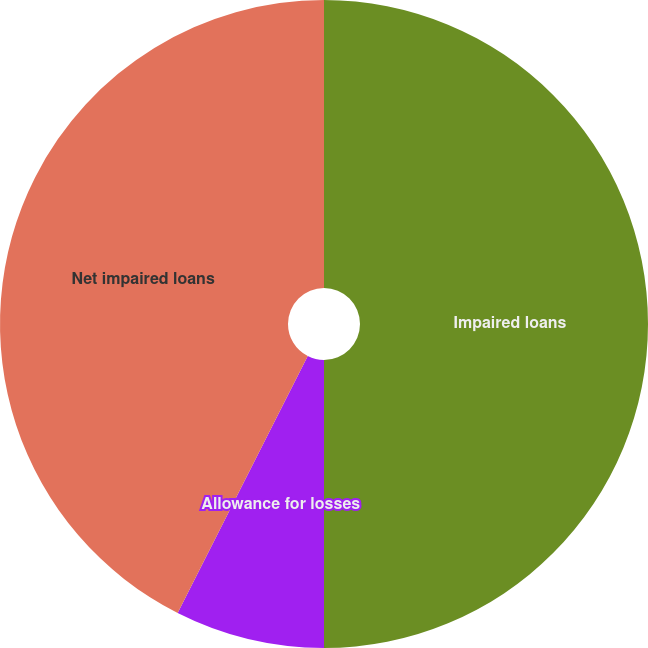<chart> <loc_0><loc_0><loc_500><loc_500><pie_chart><fcel>Impaired loans<fcel>Allowance for losses<fcel>Net impaired loans<nl><fcel>50.0%<fcel>7.46%<fcel>42.54%<nl></chart> 